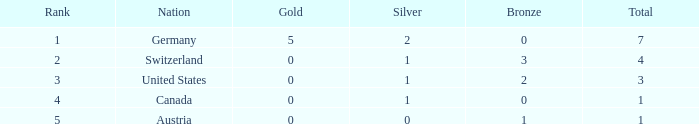Can you parse all the data within this table? {'header': ['Rank', 'Nation', 'Gold', 'Silver', 'Bronze', 'Total'], 'rows': [['1', 'Germany', '5', '2', '0', '7'], ['2', 'Switzerland', '0', '1', '3', '4'], ['3', 'United States', '0', '1', '2', '3'], ['4', 'Canada', '0', '1', '0', '1'], ['5', 'Austria', '0', '0', '1', '1']]} What is the aggregate amount of bronze when the overall is less than 1? None. 